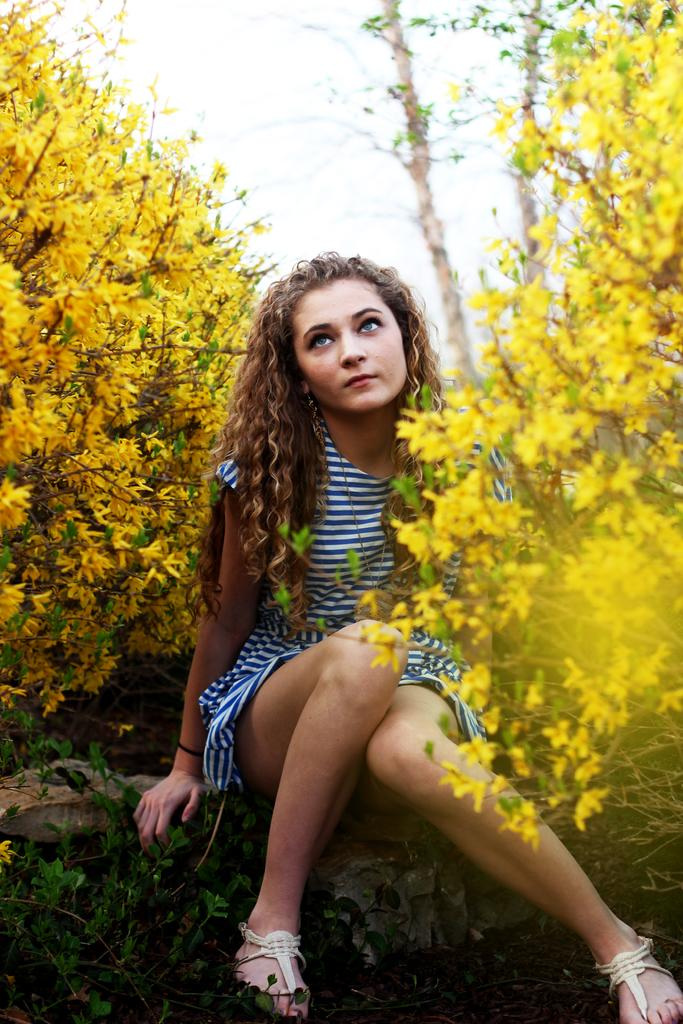What is the girl doing in the image? The girl is sitting on a stone in the image. What can be seen near the girl? There are yellow flowers on either side of the girl. What type of plants are at the bottom of the image? There are green plants at the bottom of the image. What type of roof can be seen above the girl in the image? There is no roof visible in the image; it appears to be an outdoor scene. How does the goose interact with the girl in the image? There is no goose present in the image. 